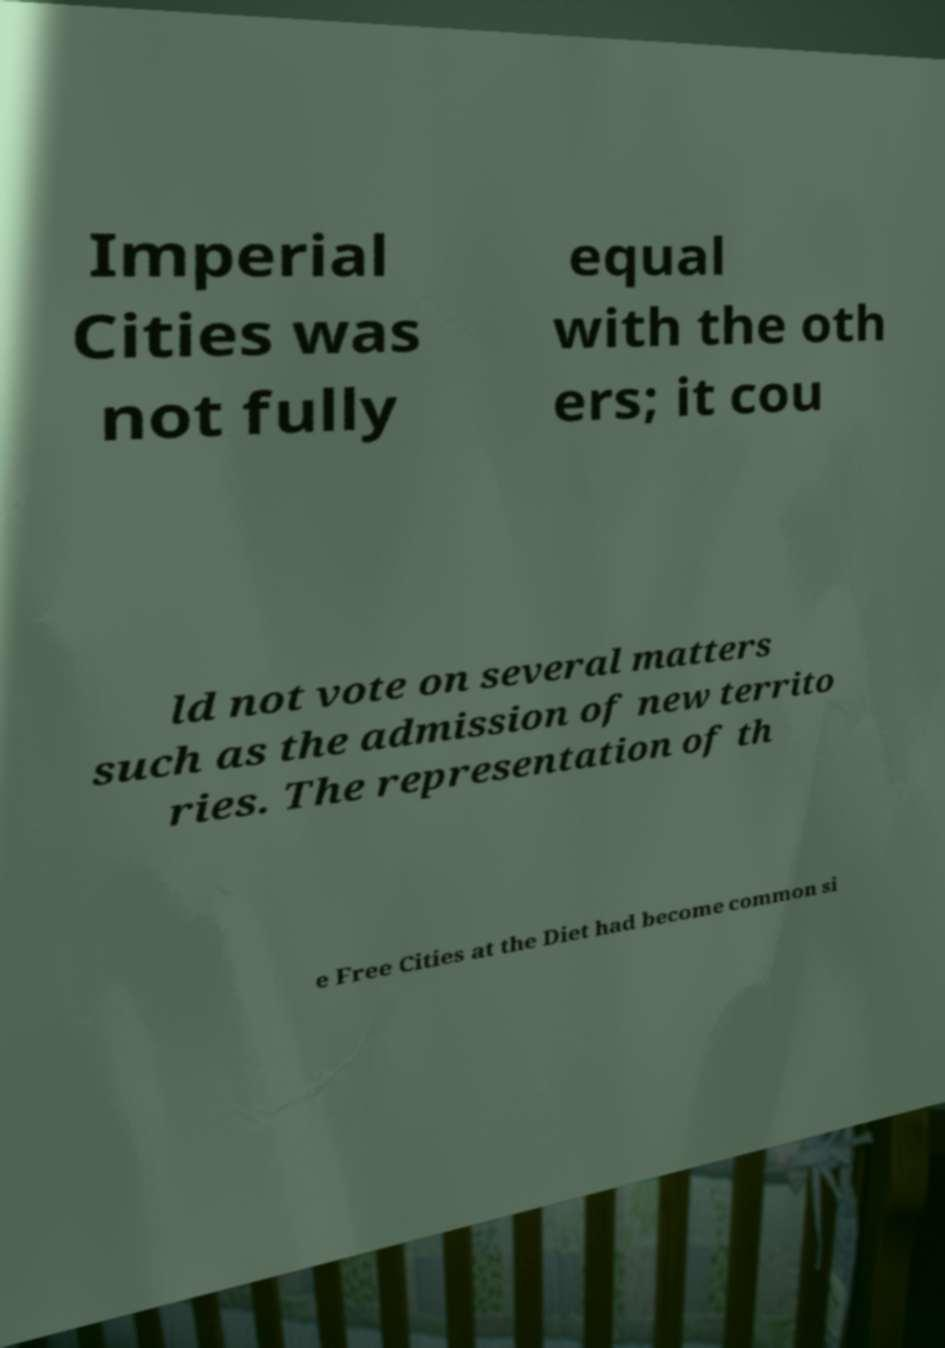For documentation purposes, I need the text within this image transcribed. Could you provide that? Imperial Cities was not fully equal with the oth ers; it cou ld not vote on several matters such as the admission of new territo ries. The representation of th e Free Cities at the Diet had become common si 